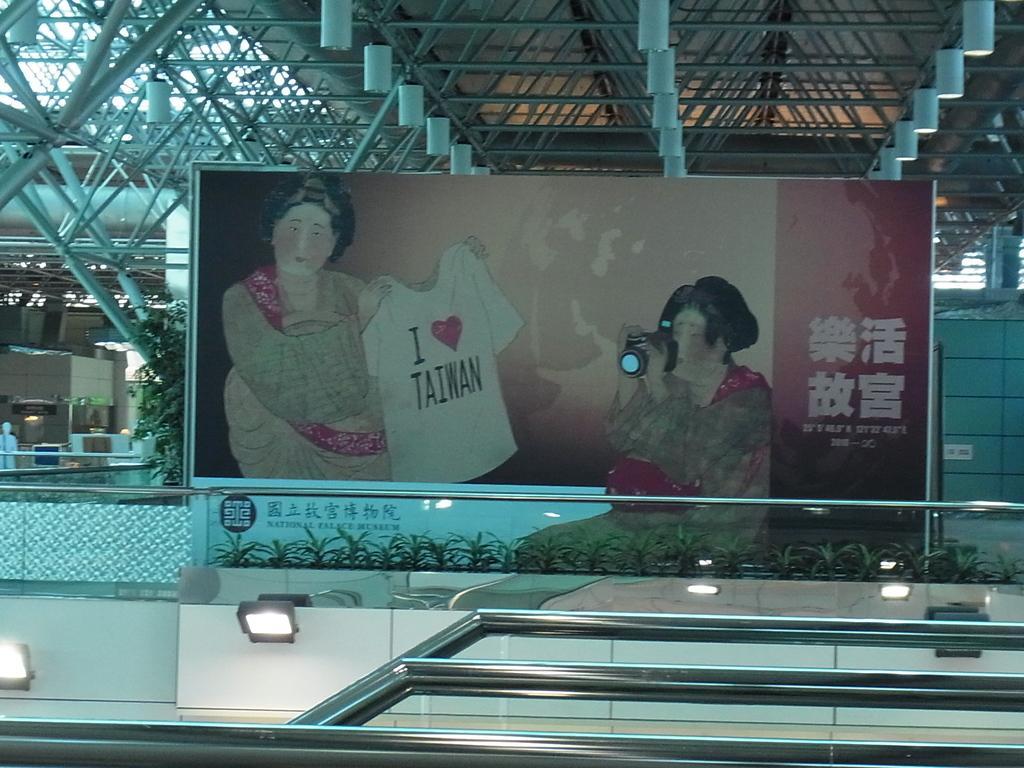Describe this image in one or two sentences. In this picture we can see a few rods and lights. There is a glass object. Through this glass object, we can see a banner. In this banner, there is a woman holding a shirt. We can see a person holding a camera, some text and a few plants. A plant is visible on the left side. There are some objects visible in the background. 